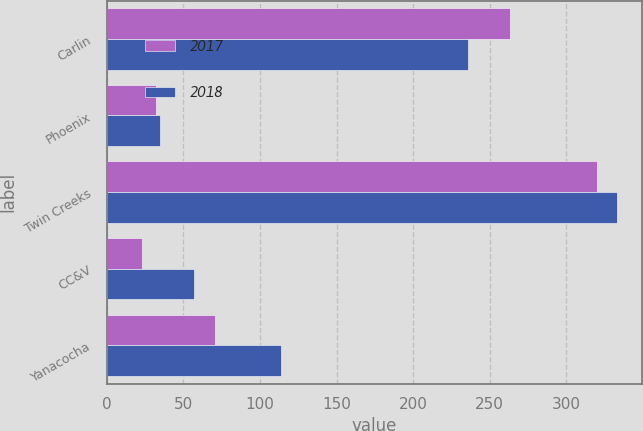<chart> <loc_0><loc_0><loc_500><loc_500><stacked_bar_chart><ecel><fcel>Carlin<fcel>Phoenix<fcel>Twin Creeks<fcel>CC&V<fcel>Yanacocha<nl><fcel>2017<fcel>263<fcel>32<fcel>320<fcel>23<fcel>71<nl><fcel>2018<fcel>236<fcel>35<fcel>333<fcel>57<fcel>114<nl></chart> 